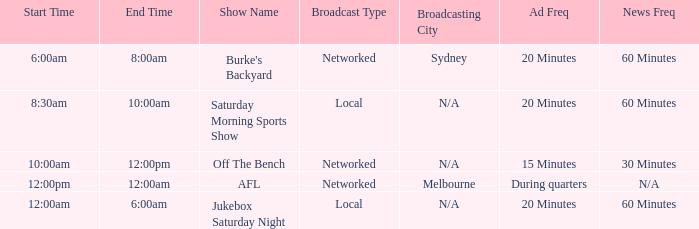What is the ad frequency for the Show Off The Bench? 15 Minutes. Parse the full table. {'header': ['Start Time', 'End Time', 'Show Name', 'Broadcast Type', 'Broadcasting City', 'Ad Freq', 'News Freq'], 'rows': [['6:00am', '8:00am', "Burke's Backyard", 'Networked', 'Sydney', '20 Minutes', '60 Minutes'], ['8:30am', '10:00am', 'Saturday Morning Sports Show', 'Local', 'N/A', '20 Minutes', '60 Minutes'], ['10:00am', '12:00pm', 'Off The Bench', 'Networked', 'N/A', '15 Minutes', '30 Minutes'], ['12:00pm', '12:00am', 'AFL', 'Networked', 'Melbourne', 'During quarters', 'N/A'], ['12:00am', '6:00am', 'Jukebox Saturday Night', 'Local', 'N/A', '20 Minutes', '60 Minutes']]} 